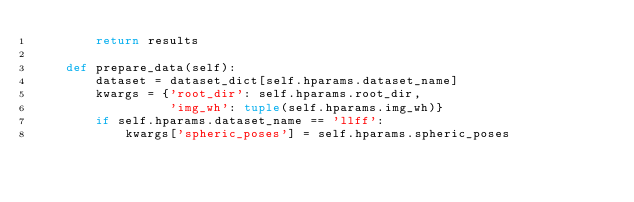<code> <loc_0><loc_0><loc_500><loc_500><_Python_>        return results

    def prepare_data(self):
        dataset = dataset_dict[self.hparams.dataset_name]
        kwargs = {'root_dir': self.hparams.root_dir,
                  'img_wh': tuple(self.hparams.img_wh)}
        if self.hparams.dataset_name == 'llff':
            kwargs['spheric_poses'] = self.hparams.spheric_poses</code> 